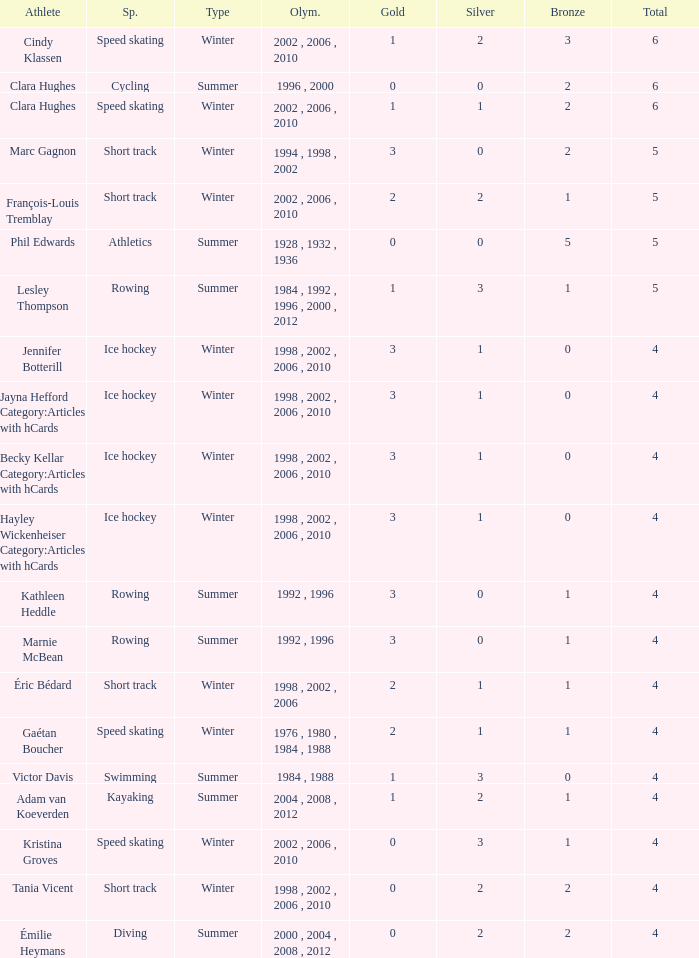What is the highest total medals winter athlete Clara Hughes has? 6.0. 